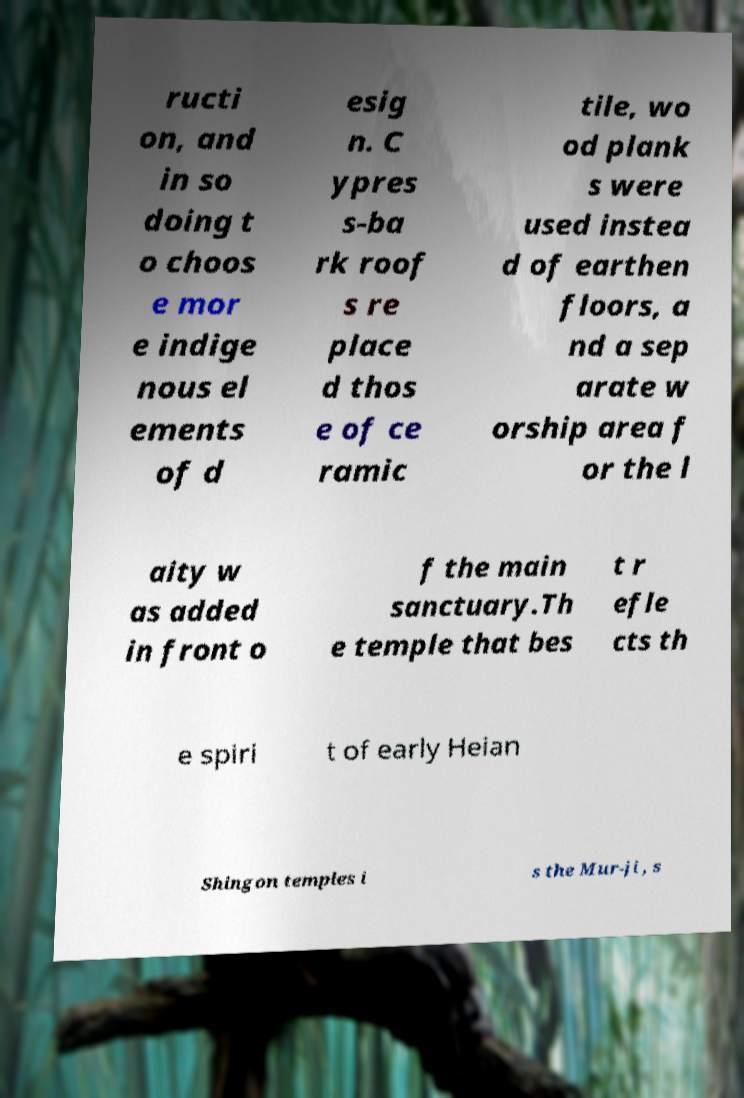There's text embedded in this image that I need extracted. Can you transcribe it verbatim? ructi on, and in so doing t o choos e mor e indige nous el ements of d esig n. C ypres s-ba rk roof s re place d thos e of ce ramic tile, wo od plank s were used instea d of earthen floors, a nd a sep arate w orship area f or the l aity w as added in front o f the main sanctuary.Th e temple that bes t r efle cts th e spiri t of early Heian Shingon temples i s the Mur-ji , s 